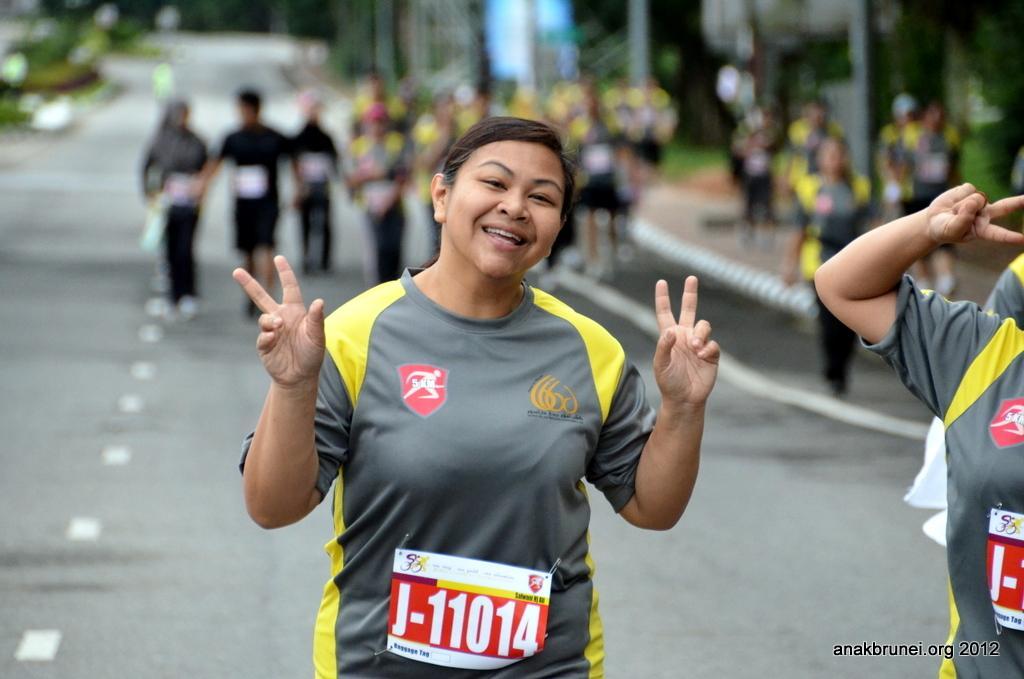In one or two sentences, can you explain what this image depicts? There is a lady wearing chest number is smiling. There is a road. In the back there are many people. And it is blurred in the background. There is a watermark on the right corner. 